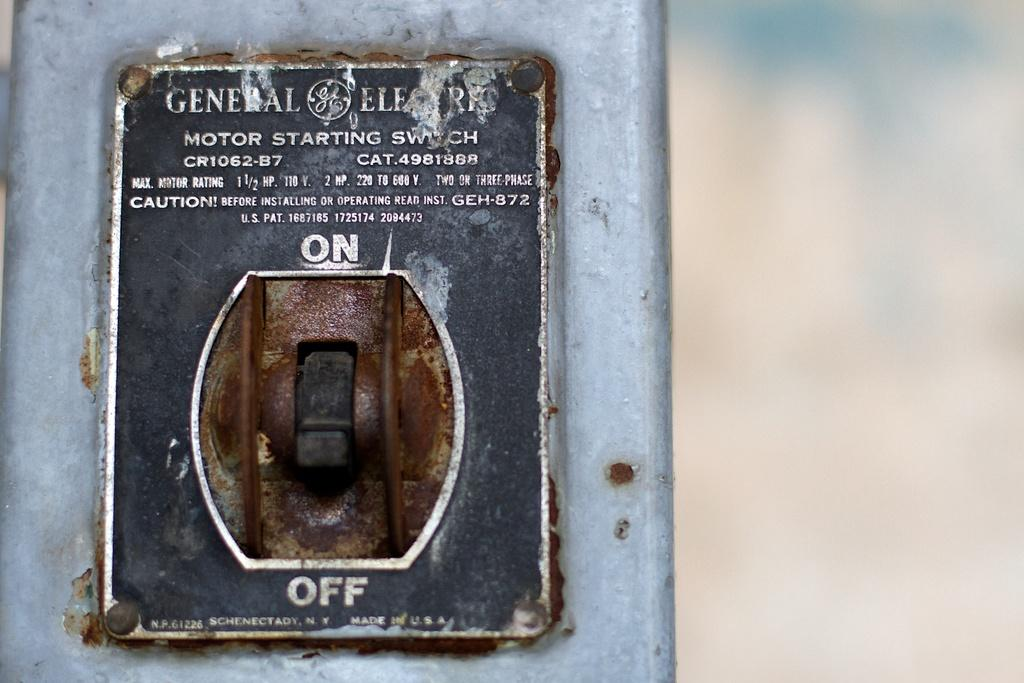<image>
Summarize the visual content of the image. GE Motor Starting Switch is the designation shown on this wall toggle. 